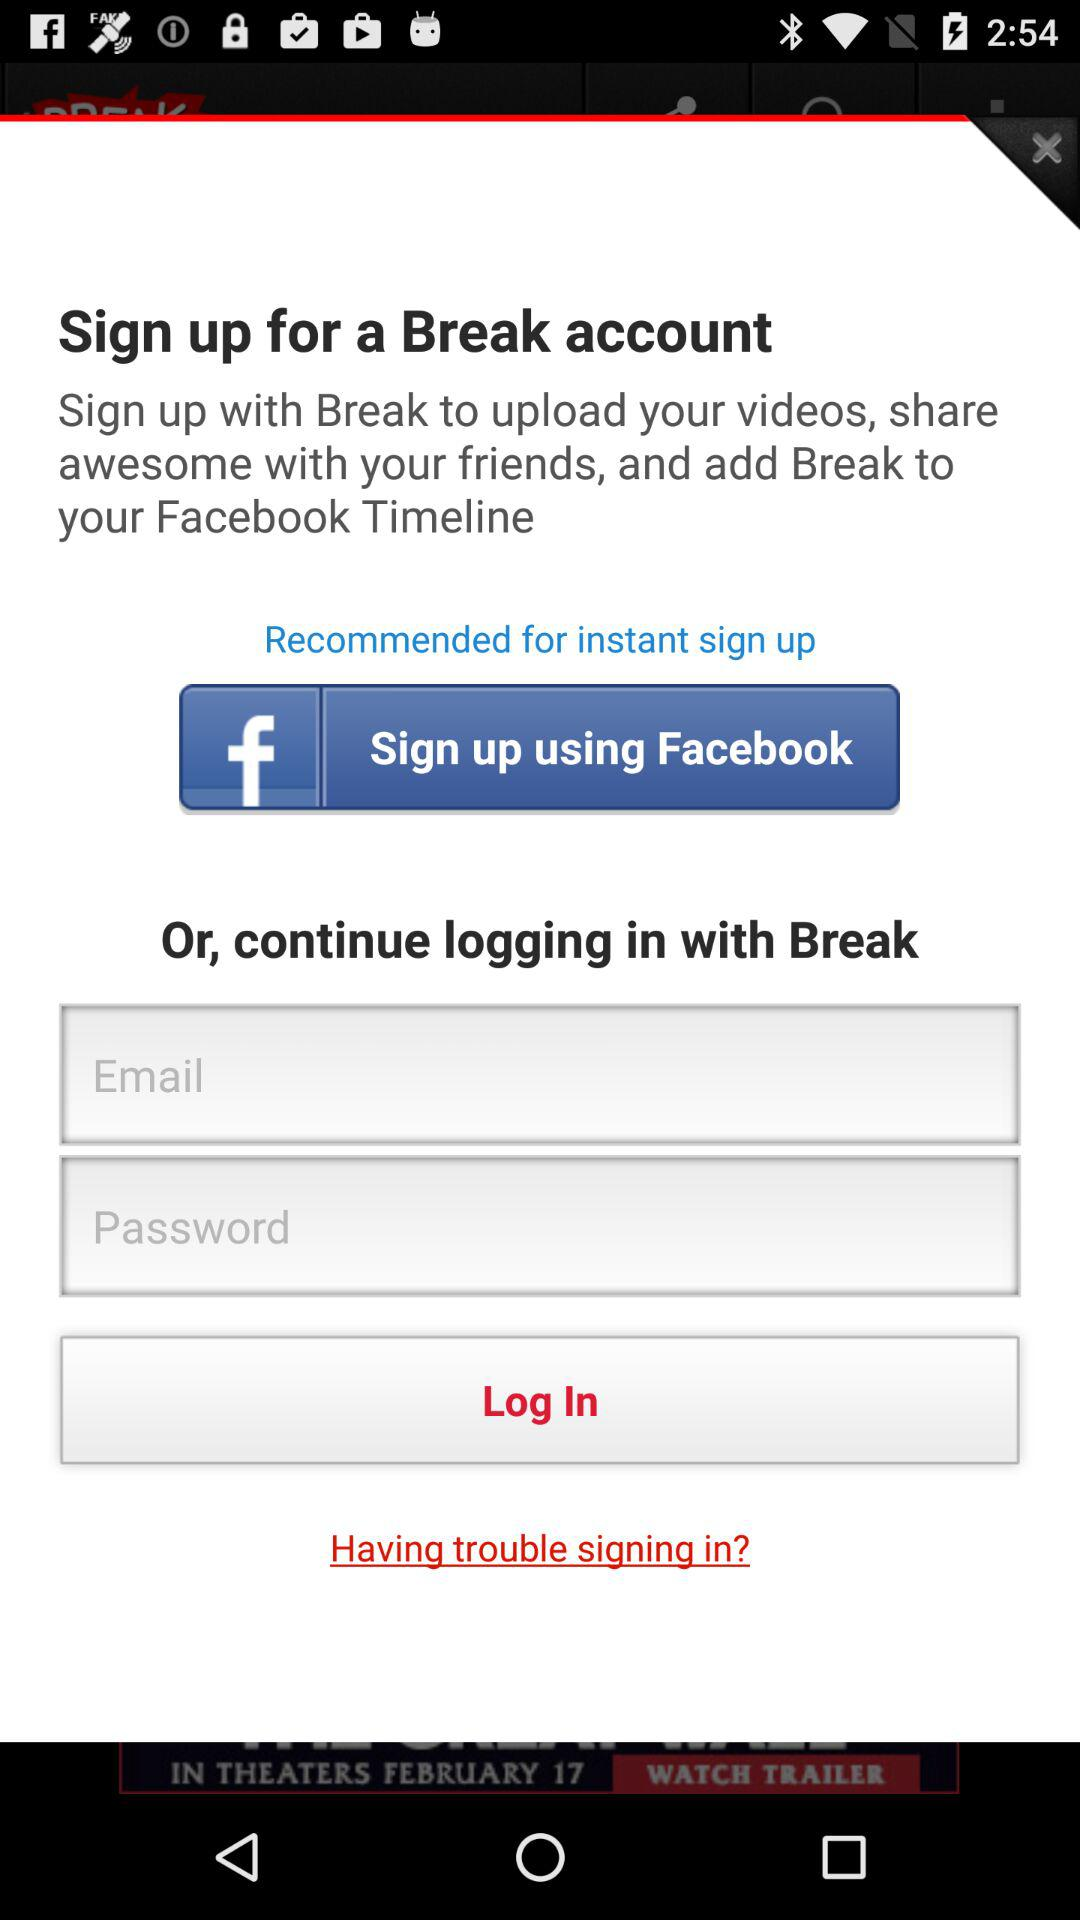Which option is recommended for instant sign up? The recommended option for instant sign up is "Facebook". 